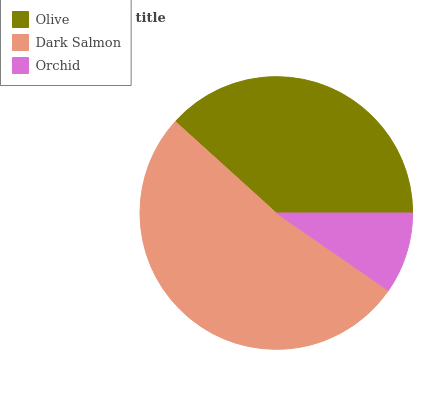Is Orchid the minimum?
Answer yes or no. Yes. Is Dark Salmon the maximum?
Answer yes or no. Yes. Is Dark Salmon the minimum?
Answer yes or no. No. Is Orchid the maximum?
Answer yes or no. No. Is Dark Salmon greater than Orchid?
Answer yes or no. Yes. Is Orchid less than Dark Salmon?
Answer yes or no. Yes. Is Orchid greater than Dark Salmon?
Answer yes or no. No. Is Dark Salmon less than Orchid?
Answer yes or no. No. Is Olive the high median?
Answer yes or no. Yes. Is Olive the low median?
Answer yes or no. Yes. Is Dark Salmon the high median?
Answer yes or no. No. Is Orchid the low median?
Answer yes or no. No. 